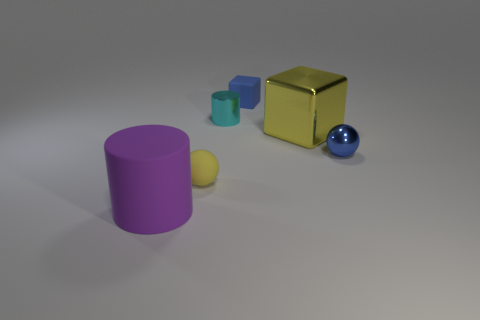There is a thing that is the same color as the large cube; what is its shape?
Ensure brevity in your answer.  Sphere. There is a large object right of the blue cube; is it the same shape as the small thing that is behind the tiny cyan thing?
Your answer should be very brief. Yes. What number of large purple matte cylinders are there?
Your response must be concise. 1. There is a yellow object that is made of the same material as the large purple cylinder; what is its shape?
Provide a short and direct response. Sphere. Is there anything else that has the same color as the rubber cylinder?
Provide a short and direct response. No. There is a matte sphere; is it the same color as the large object right of the cyan metal object?
Provide a succinct answer. Yes. Is the number of objects to the left of the cyan metal object less than the number of tiny shiny cylinders?
Your answer should be very brief. No. What is the large object that is on the right side of the small blue cube made of?
Keep it short and to the point. Metal. How many other objects are the same size as the blue metallic sphere?
Provide a short and direct response. 3. There is a blue metallic object; does it have the same size as the cylinder that is behind the yellow matte thing?
Give a very brief answer. Yes. 